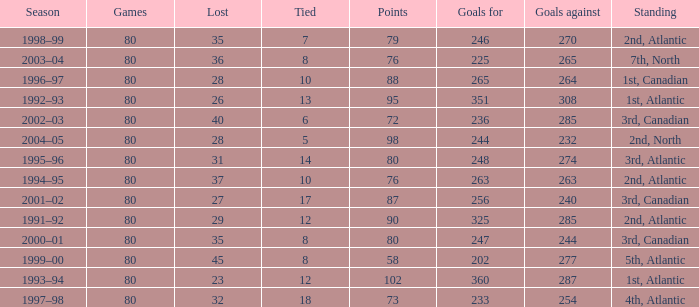How many goals against have 58 points? 277.0. 